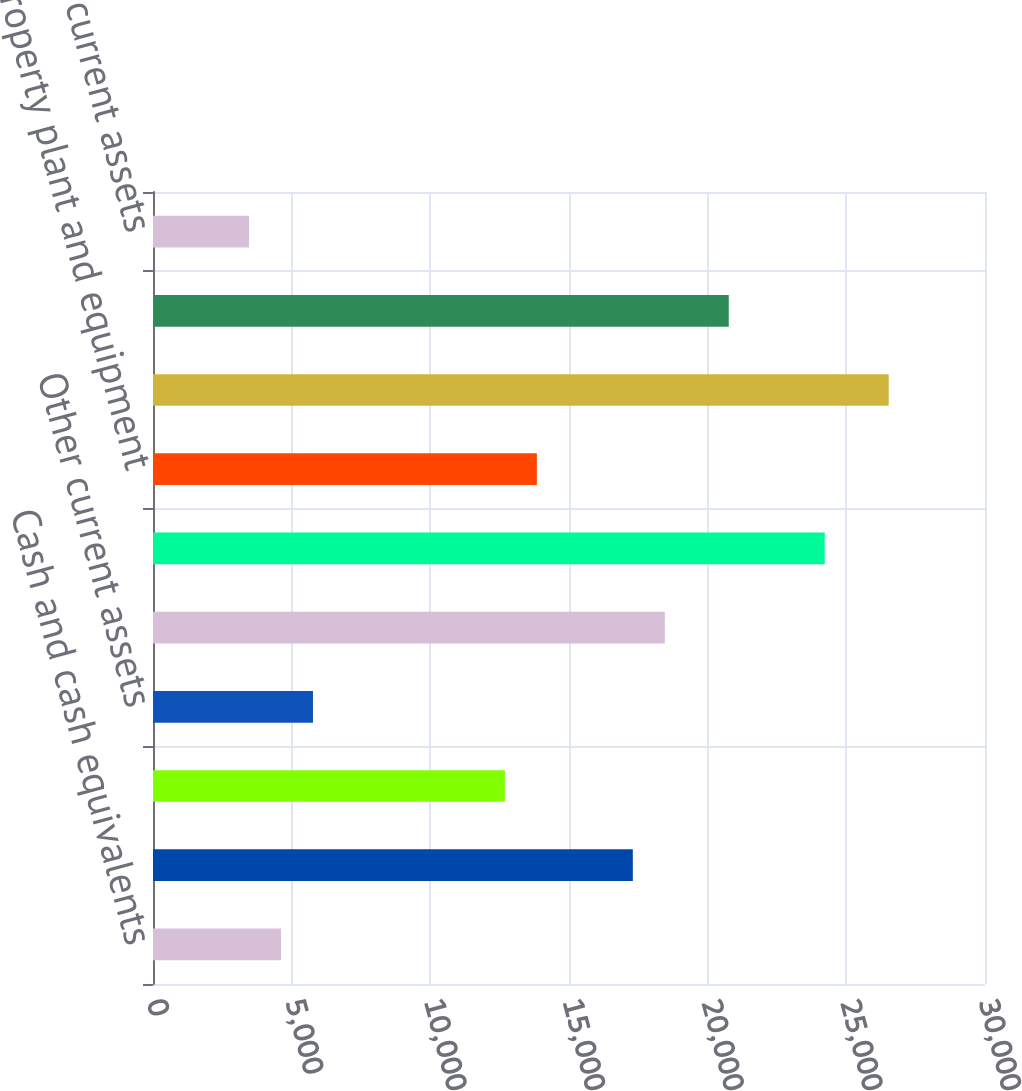Convert chart to OTSL. <chart><loc_0><loc_0><loc_500><loc_500><bar_chart><fcel>Cash and cash equivalents<fcel>Accounts and notes receivable<fcel>Inventories<fcel>Other current assets<fcel>Current assets held for sale<fcel>Total current assets<fcel>Property plant and equipment<fcel>Goodwill<fcel>Intangibles net<fcel>Other non-current assets<nl><fcel>4615<fcel>17301.3<fcel>12688.1<fcel>5768.3<fcel>18454.6<fcel>24221.1<fcel>13841.4<fcel>26527.7<fcel>20761.2<fcel>3461.7<nl></chart> 